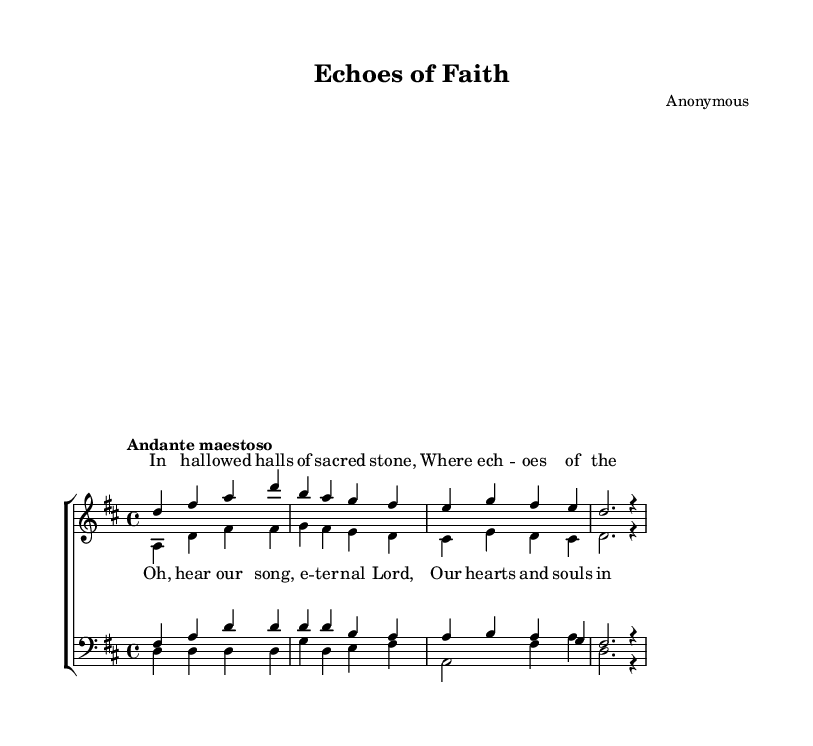What is the key signature of this music? The key signature of the piece is D major, which has two sharps (F# and C#). This can be determined by looking at the key signature indicated at the beginning of the score, before the staff.
Answer: D major What is the time signature of the piece? The time signature shown at the beginning of the music is 4/4, indicating that there are four beats in each measure and a quarter note receives one beat. This information is also stated at the beginning of the score.
Answer: 4/4 What is the tempo marking of the music? The tempo marking given at the start of the piece is "Andante maestoso", which suggests a moderately slow tempo with a dignified character. This marking gives performers an idea of how fast the music should be played.
Answer: Andante maestoso What voices are present in this piece? The piece is scored for soprano, alto, tenor, and bass, which are the four main voice parts in choral music. This can be observed by looking at the labels provided for each staff in the score.
Answer: Soprano, alto, tenor, bass How many measures are in the soprano music? The soprano part consists of four measures. This can be counted by the number of vertical lines (barlines) that separate each measure within the staff.
Answer: Four What type of song is this piece part of? This piece is an opera, reflecting the characteristics of grand choral arrangements typical of the Romantic era, where music is composed for performance with dramatic narratives. This can be inferred from the context and style of the music presented.
Answer: Opera What does the chorus lyrics express? The lyrics for the chorus express a plea or devotion to the "eternal Lord," aligning with themes of worship often found in church hymns. This is interpreted from the emotional content of the text noted for the chorus within the score.
Answer: Devotion 